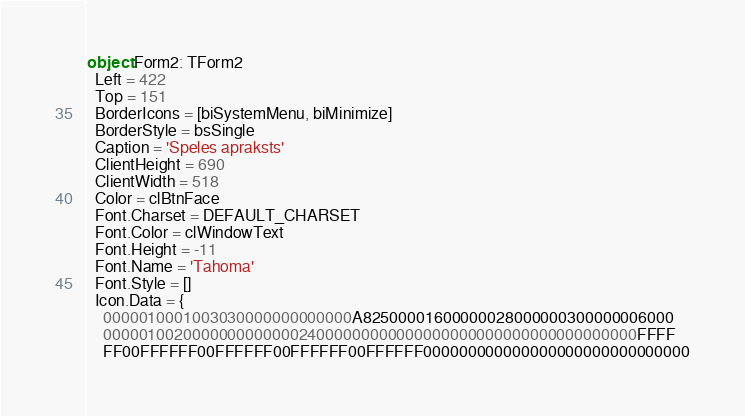<code> <loc_0><loc_0><loc_500><loc_500><_Pascal_>object Form2: TForm2
  Left = 422
  Top = 151
  BorderIcons = [biSystemMenu, biMinimize]
  BorderStyle = bsSingle
  Caption = 'Speles apraksts'
  ClientHeight = 690
  ClientWidth = 518
  Color = clBtnFace
  Font.Charset = DEFAULT_CHARSET
  Font.Color = clWindowText
  Font.Height = -11
  Font.Name = 'Tahoma'
  Font.Style = []
  Icon.Data = {
    0000010001003030000000000000A82500001600000028000000300000006000
    000001002000000000000024000000000000000000000000000000000000FFFF
    FF00FFFFFF00FFFFFF00FFFFFF00FFFFFF000000000000000000000000000000</code> 